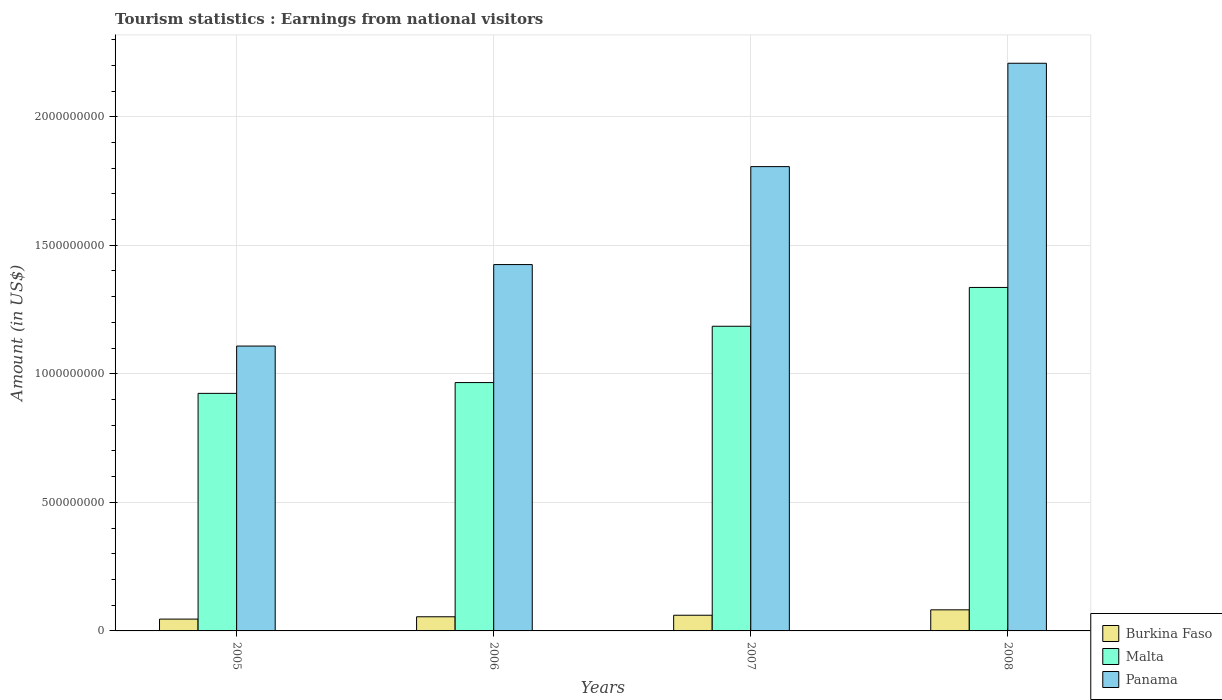How many groups of bars are there?
Ensure brevity in your answer.  4. How many bars are there on the 2nd tick from the left?
Ensure brevity in your answer.  3. How many bars are there on the 2nd tick from the right?
Provide a succinct answer. 3. What is the label of the 4th group of bars from the left?
Your answer should be compact. 2008. What is the earnings from national visitors in Malta in 2005?
Offer a terse response. 9.24e+08. Across all years, what is the maximum earnings from national visitors in Burkina Faso?
Provide a short and direct response. 8.20e+07. Across all years, what is the minimum earnings from national visitors in Burkina Faso?
Provide a short and direct response. 4.60e+07. What is the total earnings from national visitors in Malta in the graph?
Keep it short and to the point. 4.41e+09. What is the difference between the earnings from national visitors in Panama in 2007 and that in 2008?
Keep it short and to the point. -4.02e+08. What is the difference between the earnings from national visitors in Malta in 2008 and the earnings from national visitors in Panama in 2006?
Offer a terse response. -8.90e+07. What is the average earnings from national visitors in Burkina Faso per year?
Make the answer very short. 6.10e+07. In the year 2008, what is the difference between the earnings from national visitors in Malta and earnings from national visitors in Panama?
Offer a terse response. -8.72e+08. What is the ratio of the earnings from national visitors in Malta in 2005 to that in 2007?
Offer a very short reply. 0.78. What is the difference between the highest and the second highest earnings from national visitors in Panama?
Provide a succinct answer. 4.02e+08. What is the difference between the highest and the lowest earnings from national visitors in Malta?
Give a very brief answer. 4.12e+08. In how many years, is the earnings from national visitors in Panama greater than the average earnings from national visitors in Panama taken over all years?
Your response must be concise. 2. Is the sum of the earnings from national visitors in Burkina Faso in 2005 and 2008 greater than the maximum earnings from national visitors in Malta across all years?
Keep it short and to the point. No. What does the 3rd bar from the left in 2006 represents?
Offer a terse response. Panama. What does the 2nd bar from the right in 2006 represents?
Give a very brief answer. Malta. Is it the case that in every year, the sum of the earnings from national visitors in Malta and earnings from national visitors in Burkina Faso is greater than the earnings from national visitors in Panama?
Provide a short and direct response. No. How many bars are there?
Ensure brevity in your answer.  12. Are all the bars in the graph horizontal?
Keep it short and to the point. No. Are the values on the major ticks of Y-axis written in scientific E-notation?
Offer a very short reply. No. Does the graph contain any zero values?
Provide a short and direct response. No. Does the graph contain grids?
Your answer should be compact. Yes. Where does the legend appear in the graph?
Keep it short and to the point. Bottom right. How many legend labels are there?
Give a very brief answer. 3. What is the title of the graph?
Your answer should be very brief. Tourism statistics : Earnings from national visitors. Does "Macedonia" appear as one of the legend labels in the graph?
Keep it short and to the point. No. What is the label or title of the X-axis?
Offer a terse response. Years. What is the label or title of the Y-axis?
Your answer should be very brief. Amount (in US$). What is the Amount (in US$) in Burkina Faso in 2005?
Give a very brief answer. 4.60e+07. What is the Amount (in US$) in Malta in 2005?
Ensure brevity in your answer.  9.24e+08. What is the Amount (in US$) in Panama in 2005?
Keep it short and to the point. 1.11e+09. What is the Amount (in US$) in Burkina Faso in 2006?
Give a very brief answer. 5.50e+07. What is the Amount (in US$) of Malta in 2006?
Offer a very short reply. 9.66e+08. What is the Amount (in US$) in Panama in 2006?
Ensure brevity in your answer.  1.42e+09. What is the Amount (in US$) in Burkina Faso in 2007?
Offer a terse response. 6.10e+07. What is the Amount (in US$) in Malta in 2007?
Make the answer very short. 1.18e+09. What is the Amount (in US$) in Panama in 2007?
Offer a terse response. 1.81e+09. What is the Amount (in US$) in Burkina Faso in 2008?
Your answer should be compact. 8.20e+07. What is the Amount (in US$) of Malta in 2008?
Ensure brevity in your answer.  1.34e+09. What is the Amount (in US$) in Panama in 2008?
Keep it short and to the point. 2.21e+09. Across all years, what is the maximum Amount (in US$) of Burkina Faso?
Offer a very short reply. 8.20e+07. Across all years, what is the maximum Amount (in US$) of Malta?
Your response must be concise. 1.34e+09. Across all years, what is the maximum Amount (in US$) of Panama?
Provide a succinct answer. 2.21e+09. Across all years, what is the minimum Amount (in US$) of Burkina Faso?
Ensure brevity in your answer.  4.60e+07. Across all years, what is the minimum Amount (in US$) in Malta?
Make the answer very short. 9.24e+08. Across all years, what is the minimum Amount (in US$) in Panama?
Your response must be concise. 1.11e+09. What is the total Amount (in US$) in Burkina Faso in the graph?
Ensure brevity in your answer.  2.44e+08. What is the total Amount (in US$) of Malta in the graph?
Provide a short and direct response. 4.41e+09. What is the total Amount (in US$) of Panama in the graph?
Provide a short and direct response. 6.55e+09. What is the difference between the Amount (in US$) of Burkina Faso in 2005 and that in 2006?
Keep it short and to the point. -9.00e+06. What is the difference between the Amount (in US$) of Malta in 2005 and that in 2006?
Make the answer very short. -4.20e+07. What is the difference between the Amount (in US$) in Panama in 2005 and that in 2006?
Give a very brief answer. -3.17e+08. What is the difference between the Amount (in US$) in Burkina Faso in 2005 and that in 2007?
Your answer should be compact. -1.50e+07. What is the difference between the Amount (in US$) in Malta in 2005 and that in 2007?
Give a very brief answer. -2.61e+08. What is the difference between the Amount (in US$) in Panama in 2005 and that in 2007?
Your response must be concise. -6.98e+08. What is the difference between the Amount (in US$) in Burkina Faso in 2005 and that in 2008?
Your response must be concise. -3.60e+07. What is the difference between the Amount (in US$) of Malta in 2005 and that in 2008?
Provide a short and direct response. -4.12e+08. What is the difference between the Amount (in US$) of Panama in 2005 and that in 2008?
Provide a short and direct response. -1.10e+09. What is the difference between the Amount (in US$) of Burkina Faso in 2006 and that in 2007?
Make the answer very short. -6.00e+06. What is the difference between the Amount (in US$) of Malta in 2006 and that in 2007?
Give a very brief answer. -2.19e+08. What is the difference between the Amount (in US$) of Panama in 2006 and that in 2007?
Give a very brief answer. -3.81e+08. What is the difference between the Amount (in US$) in Burkina Faso in 2006 and that in 2008?
Make the answer very short. -2.70e+07. What is the difference between the Amount (in US$) of Malta in 2006 and that in 2008?
Provide a succinct answer. -3.70e+08. What is the difference between the Amount (in US$) of Panama in 2006 and that in 2008?
Offer a terse response. -7.83e+08. What is the difference between the Amount (in US$) of Burkina Faso in 2007 and that in 2008?
Your answer should be compact. -2.10e+07. What is the difference between the Amount (in US$) in Malta in 2007 and that in 2008?
Offer a terse response. -1.51e+08. What is the difference between the Amount (in US$) of Panama in 2007 and that in 2008?
Your response must be concise. -4.02e+08. What is the difference between the Amount (in US$) in Burkina Faso in 2005 and the Amount (in US$) in Malta in 2006?
Offer a terse response. -9.20e+08. What is the difference between the Amount (in US$) in Burkina Faso in 2005 and the Amount (in US$) in Panama in 2006?
Make the answer very short. -1.38e+09. What is the difference between the Amount (in US$) of Malta in 2005 and the Amount (in US$) of Panama in 2006?
Your answer should be very brief. -5.01e+08. What is the difference between the Amount (in US$) in Burkina Faso in 2005 and the Amount (in US$) in Malta in 2007?
Ensure brevity in your answer.  -1.14e+09. What is the difference between the Amount (in US$) in Burkina Faso in 2005 and the Amount (in US$) in Panama in 2007?
Keep it short and to the point. -1.76e+09. What is the difference between the Amount (in US$) of Malta in 2005 and the Amount (in US$) of Panama in 2007?
Make the answer very short. -8.82e+08. What is the difference between the Amount (in US$) of Burkina Faso in 2005 and the Amount (in US$) of Malta in 2008?
Offer a terse response. -1.29e+09. What is the difference between the Amount (in US$) in Burkina Faso in 2005 and the Amount (in US$) in Panama in 2008?
Make the answer very short. -2.16e+09. What is the difference between the Amount (in US$) of Malta in 2005 and the Amount (in US$) of Panama in 2008?
Your response must be concise. -1.28e+09. What is the difference between the Amount (in US$) in Burkina Faso in 2006 and the Amount (in US$) in Malta in 2007?
Your answer should be very brief. -1.13e+09. What is the difference between the Amount (in US$) of Burkina Faso in 2006 and the Amount (in US$) of Panama in 2007?
Keep it short and to the point. -1.75e+09. What is the difference between the Amount (in US$) of Malta in 2006 and the Amount (in US$) of Panama in 2007?
Your answer should be very brief. -8.40e+08. What is the difference between the Amount (in US$) in Burkina Faso in 2006 and the Amount (in US$) in Malta in 2008?
Give a very brief answer. -1.28e+09. What is the difference between the Amount (in US$) of Burkina Faso in 2006 and the Amount (in US$) of Panama in 2008?
Offer a terse response. -2.15e+09. What is the difference between the Amount (in US$) in Malta in 2006 and the Amount (in US$) in Panama in 2008?
Ensure brevity in your answer.  -1.24e+09. What is the difference between the Amount (in US$) in Burkina Faso in 2007 and the Amount (in US$) in Malta in 2008?
Give a very brief answer. -1.28e+09. What is the difference between the Amount (in US$) in Burkina Faso in 2007 and the Amount (in US$) in Panama in 2008?
Keep it short and to the point. -2.15e+09. What is the difference between the Amount (in US$) in Malta in 2007 and the Amount (in US$) in Panama in 2008?
Offer a very short reply. -1.02e+09. What is the average Amount (in US$) of Burkina Faso per year?
Provide a succinct answer. 6.10e+07. What is the average Amount (in US$) in Malta per year?
Provide a short and direct response. 1.10e+09. What is the average Amount (in US$) in Panama per year?
Your answer should be compact. 1.64e+09. In the year 2005, what is the difference between the Amount (in US$) of Burkina Faso and Amount (in US$) of Malta?
Keep it short and to the point. -8.78e+08. In the year 2005, what is the difference between the Amount (in US$) of Burkina Faso and Amount (in US$) of Panama?
Your answer should be compact. -1.06e+09. In the year 2005, what is the difference between the Amount (in US$) of Malta and Amount (in US$) of Panama?
Your response must be concise. -1.84e+08. In the year 2006, what is the difference between the Amount (in US$) in Burkina Faso and Amount (in US$) in Malta?
Keep it short and to the point. -9.11e+08. In the year 2006, what is the difference between the Amount (in US$) of Burkina Faso and Amount (in US$) of Panama?
Offer a terse response. -1.37e+09. In the year 2006, what is the difference between the Amount (in US$) in Malta and Amount (in US$) in Panama?
Keep it short and to the point. -4.59e+08. In the year 2007, what is the difference between the Amount (in US$) of Burkina Faso and Amount (in US$) of Malta?
Offer a very short reply. -1.12e+09. In the year 2007, what is the difference between the Amount (in US$) in Burkina Faso and Amount (in US$) in Panama?
Your response must be concise. -1.74e+09. In the year 2007, what is the difference between the Amount (in US$) in Malta and Amount (in US$) in Panama?
Your answer should be very brief. -6.21e+08. In the year 2008, what is the difference between the Amount (in US$) in Burkina Faso and Amount (in US$) in Malta?
Keep it short and to the point. -1.25e+09. In the year 2008, what is the difference between the Amount (in US$) in Burkina Faso and Amount (in US$) in Panama?
Your response must be concise. -2.13e+09. In the year 2008, what is the difference between the Amount (in US$) in Malta and Amount (in US$) in Panama?
Give a very brief answer. -8.72e+08. What is the ratio of the Amount (in US$) in Burkina Faso in 2005 to that in 2006?
Provide a succinct answer. 0.84. What is the ratio of the Amount (in US$) in Malta in 2005 to that in 2006?
Ensure brevity in your answer.  0.96. What is the ratio of the Amount (in US$) in Panama in 2005 to that in 2006?
Offer a very short reply. 0.78. What is the ratio of the Amount (in US$) in Burkina Faso in 2005 to that in 2007?
Offer a very short reply. 0.75. What is the ratio of the Amount (in US$) of Malta in 2005 to that in 2007?
Your answer should be compact. 0.78. What is the ratio of the Amount (in US$) of Panama in 2005 to that in 2007?
Your response must be concise. 0.61. What is the ratio of the Amount (in US$) of Burkina Faso in 2005 to that in 2008?
Your response must be concise. 0.56. What is the ratio of the Amount (in US$) in Malta in 2005 to that in 2008?
Offer a very short reply. 0.69. What is the ratio of the Amount (in US$) of Panama in 2005 to that in 2008?
Make the answer very short. 0.5. What is the ratio of the Amount (in US$) of Burkina Faso in 2006 to that in 2007?
Your answer should be very brief. 0.9. What is the ratio of the Amount (in US$) in Malta in 2006 to that in 2007?
Your answer should be compact. 0.82. What is the ratio of the Amount (in US$) of Panama in 2006 to that in 2007?
Your response must be concise. 0.79. What is the ratio of the Amount (in US$) of Burkina Faso in 2006 to that in 2008?
Offer a very short reply. 0.67. What is the ratio of the Amount (in US$) in Malta in 2006 to that in 2008?
Give a very brief answer. 0.72. What is the ratio of the Amount (in US$) of Panama in 2006 to that in 2008?
Ensure brevity in your answer.  0.65. What is the ratio of the Amount (in US$) in Burkina Faso in 2007 to that in 2008?
Provide a short and direct response. 0.74. What is the ratio of the Amount (in US$) of Malta in 2007 to that in 2008?
Your answer should be very brief. 0.89. What is the ratio of the Amount (in US$) in Panama in 2007 to that in 2008?
Offer a very short reply. 0.82. What is the difference between the highest and the second highest Amount (in US$) of Burkina Faso?
Your response must be concise. 2.10e+07. What is the difference between the highest and the second highest Amount (in US$) of Malta?
Make the answer very short. 1.51e+08. What is the difference between the highest and the second highest Amount (in US$) of Panama?
Give a very brief answer. 4.02e+08. What is the difference between the highest and the lowest Amount (in US$) of Burkina Faso?
Your response must be concise. 3.60e+07. What is the difference between the highest and the lowest Amount (in US$) in Malta?
Provide a short and direct response. 4.12e+08. What is the difference between the highest and the lowest Amount (in US$) in Panama?
Give a very brief answer. 1.10e+09. 